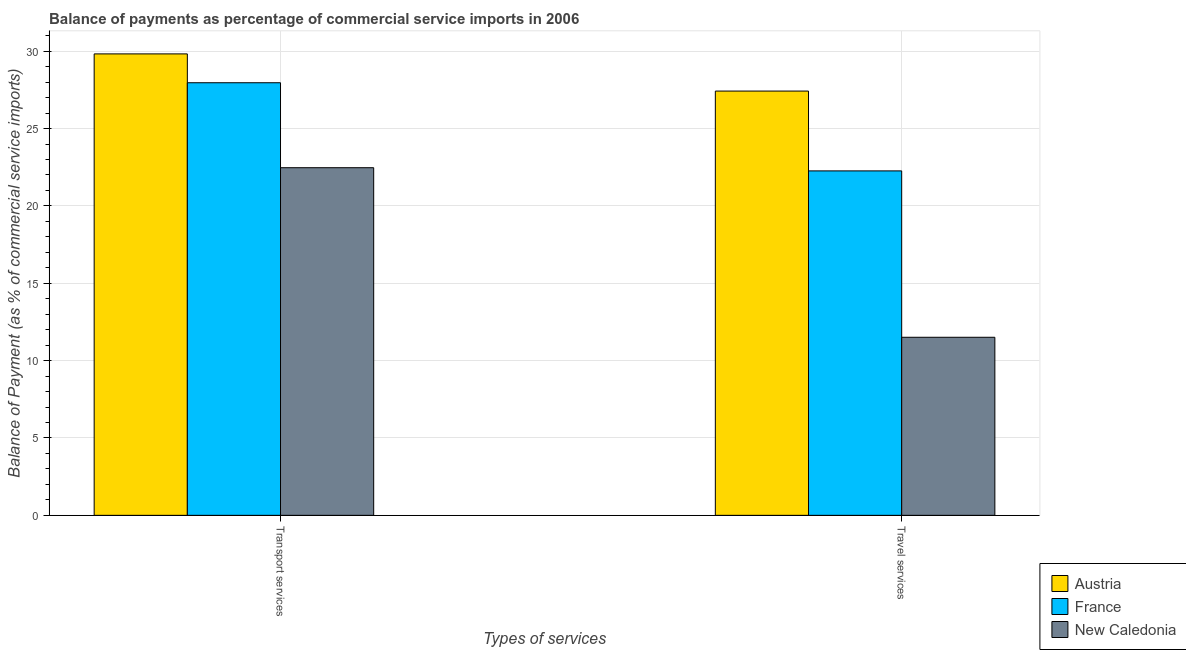Are the number of bars on each tick of the X-axis equal?
Provide a succinct answer. Yes. How many bars are there on the 1st tick from the left?
Your response must be concise. 3. How many bars are there on the 1st tick from the right?
Keep it short and to the point. 3. What is the label of the 2nd group of bars from the left?
Give a very brief answer. Travel services. What is the balance of payments of transport services in Austria?
Offer a very short reply. 29.82. Across all countries, what is the maximum balance of payments of travel services?
Keep it short and to the point. 27.42. Across all countries, what is the minimum balance of payments of transport services?
Offer a very short reply. 22.47. In which country was the balance of payments of travel services minimum?
Offer a very short reply. New Caledonia. What is the total balance of payments of travel services in the graph?
Your response must be concise. 61.19. What is the difference between the balance of payments of travel services in New Caledonia and that in France?
Your response must be concise. -10.75. What is the difference between the balance of payments of transport services in New Caledonia and the balance of payments of travel services in Austria?
Your answer should be compact. -4.95. What is the average balance of payments of transport services per country?
Make the answer very short. 26.75. What is the difference between the balance of payments of travel services and balance of payments of transport services in New Caledonia?
Give a very brief answer. -10.96. In how many countries, is the balance of payments of transport services greater than 21 %?
Make the answer very short. 3. What is the ratio of the balance of payments of transport services in France to that in New Caledonia?
Your response must be concise. 1.24. What does the 3rd bar from the left in Transport services represents?
Your answer should be compact. New Caledonia. What does the 1st bar from the right in Transport services represents?
Ensure brevity in your answer.  New Caledonia. How many bars are there?
Give a very brief answer. 6. What is the difference between two consecutive major ticks on the Y-axis?
Provide a succinct answer. 5. Are the values on the major ticks of Y-axis written in scientific E-notation?
Offer a terse response. No. Does the graph contain any zero values?
Offer a very short reply. No. Where does the legend appear in the graph?
Provide a short and direct response. Bottom right. What is the title of the graph?
Provide a short and direct response. Balance of payments as percentage of commercial service imports in 2006. What is the label or title of the X-axis?
Offer a very short reply. Types of services. What is the label or title of the Y-axis?
Ensure brevity in your answer.  Balance of Payment (as % of commercial service imports). What is the Balance of Payment (as % of commercial service imports) of Austria in Transport services?
Provide a succinct answer. 29.82. What is the Balance of Payment (as % of commercial service imports) in France in Transport services?
Your answer should be very brief. 27.96. What is the Balance of Payment (as % of commercial service imports) of New Caledonia in Transport services?
Keep it short and to the point. 22.47. What is the Balance of Payment (as % of commercial service imports) in Austria in Travel services?
Make the answer very short. 27.42. What is the Balance of Payment (as % of commercial service imports) of France in Travel services?
Offer a very short reply. 22.26. What is the Balance of Payment (as % of commercial service imports) in New Caledonia in Travel services?
Your response must be concise. 11.51. Across all Types of services, what is the maximum Balance of Payment (as % of commercial service imports) of Austria?
Keep it short and to the point. 29.82. Across all Types of services, what is the maximum Balance of Payment (as % of commercial service imports) of France?
Offer a terse response. 27.96. Across all Types of services, what is the maximum Balance of Payment (as % of commercial service imports) of New Caledonia?
Ensure brevity in your answer.  22.47. Across all Types of services, what is the minimum Balance of Payment (as % of commercial service imports) in Austria?
Offer a very short reply. 27.42. Across all Types of services, what is the minimum Balance of Payment (as % of commercial service imports) of France?
Ensure brevity in your answer.  22.26. Across all Types of services, what is the minimum Balance of Payment (as % of commercial service imports) in New Caledonia?
Your answer should be compact. 11.51. What is the total Balance of Payment (as % of commercial service imports) in Austria in the graph?
Give a very brief answer. 57.25. What is the total Balance of Payment (as % of commercial service imports) in France in the graph?
Keep it short and to the point. 50.22. What is the total Balance of Payment (as % of commercial service imports) in New Caledonia in the graph?
Ensure brevity in your answer.  33.98. What is the difference between the Balance of Payment (as % of commercial service imports) in Austria in Transport services and that in Travel services?
Offer a terse response. 2.4. What is the difference between the Balance of Payment (as % of commercial service imports) of France in Transport services and that in Travel services?
Ensure brevity in your answer.  5.7. What is the difference between the Balance of Payment (as % of commercial service imports) of New Caledonia in Transport services and that in Travel services?
Ensure brevity in your answer.  10.96. What is the difference between the Balance of Payment (as % of commercial service imports) in Austria in Transport services and the Balance of Payment (as % of commercial service imports) in France in Travel services?
Make the answer very short. 7.56. What is the difference between the Balance of Payment (as % of commercial service imports) in Austria in Transport services and the Balance of Payment (as % of commercial service imports) in New Caledonia in Travel services?
Your response must be concise. 18.32. What is the difference between the Balance of Payment (as % of commercial service imports) in France in Transport services and the Balance of Payment (as % of commercial service imports) in New Caledonia in Travel services?
Make the answer very short. 16.45. What is the average Balance of Payment (as % of commercial service imports) in Austria per Types of services?
Your answer should be very brief. 28.62. What is the average Balance of Payment (as % of commercial service imports) of France per Types of services?
Provide a short and direct response. 25.11. What is the average Balance of Payment (as % of commercial service imports) of New Caledonia per Types of services?
Keep it short and to the point. 16.99. What is the difference between the Balance of Payment (as % of commercial service imports) in Austria and Balance of Payment (as % of commercial service imports) in France in Transport services?
Provide a short and direct response. 1.86. What is the difference between the Balance of Payment (as % of commercial service imports) of Austria and Balance of Payment (as % of commercial service imports) of New Caledonia in Transport services?
Provide a short and direct response. 7.36. What is the difference between the Balance of Payment (as % of commercial service imports) in France and Balance of Payment (as % of commercial service imports) in New Caledonia in Transport services?
Your response must be concise. 5.49. What is the difference between the Balance of Payment (as % of commercial service imports) of Austria and Balance of Payment (as % of commercial service imports) of France in Travel services?
Offer a terse response. 5.16. What is the difference between the Balance of Payment (as % of commercial service imports) in Austria and Balance of Payment (as % of commercial service imports) in New Caledonia in Travel services?
Your answer should be very brief. 15.91. What is the difference between the Balance of Payment (as % of commercial service imports) of France and Balance of Payment (as % of commercial service imports) of New Caledonia in Travel services?
Give a very brief answer. 10.75. What is the ratio of the Balance of Payment (as % of commercial service imports) in Austria in Transport services to that in Travel services?
Provide a short and direct response. 1.09. What is the ratio of the Balance of Payment (as % of commercial service imports) of France in Transport services to that in Travel services?
Ensure brevity in your answer.  1.26. What is the ratio of the Balance of Payment (as % of commercial service imports) in New Caledonia in Transport services to that in Travel services?
Ensure brevity in your answer.  1.95. What is the difference between the highest and the second highest Balance of Payment (as % of commercial service imports) in Austria?
Your answer should be very brief. 2.4. What is the difference between the highest and the second highest Balance of Payment (as % of commercial service imports) in France?
Offer a very short reply. 5.7. What is the difference between the highest and the second highest Balance of Payment (as % of commercial service imports) of New Caledonia?
Make the answer very short. 10.96. What is the difference between the highest and the lowest Balance of Payment (as % of commercial service imports) in Austria?
Provide a succinct answer. 2.4. What is the difference between the highest and the lowest Balance of Payment (as % of commercial service imports) of France?
Make the answer very short. 5.7. What is the difference between the highest and the lowest Balance of Payment (as % of commercial service imports) in New Caledonia?
Ensure brevity in your answer.  10.96. 